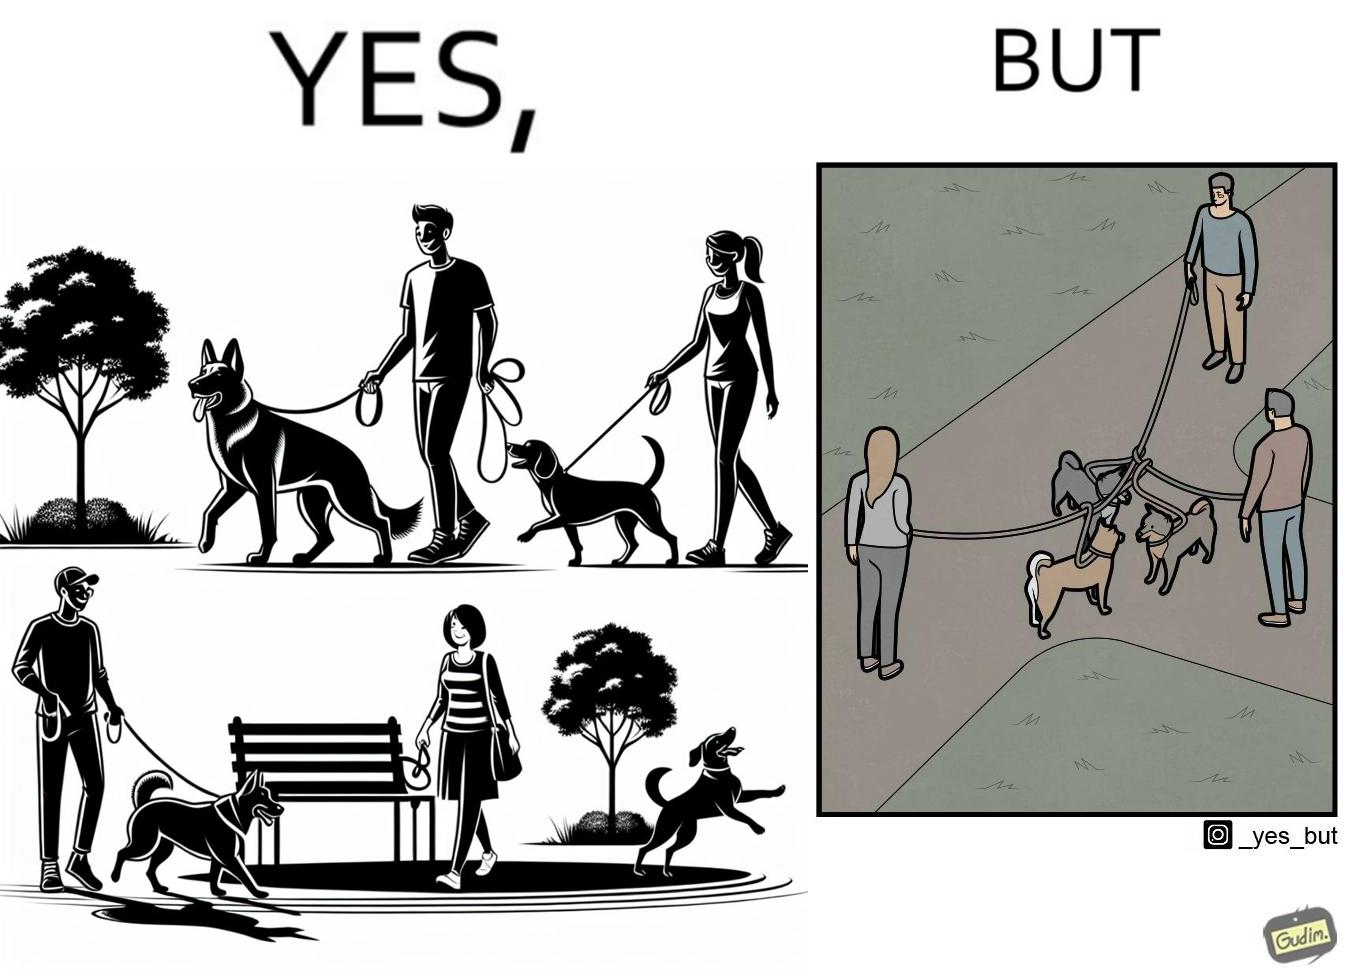Would you classify this image as satirical? Yes, this image is satirical. 